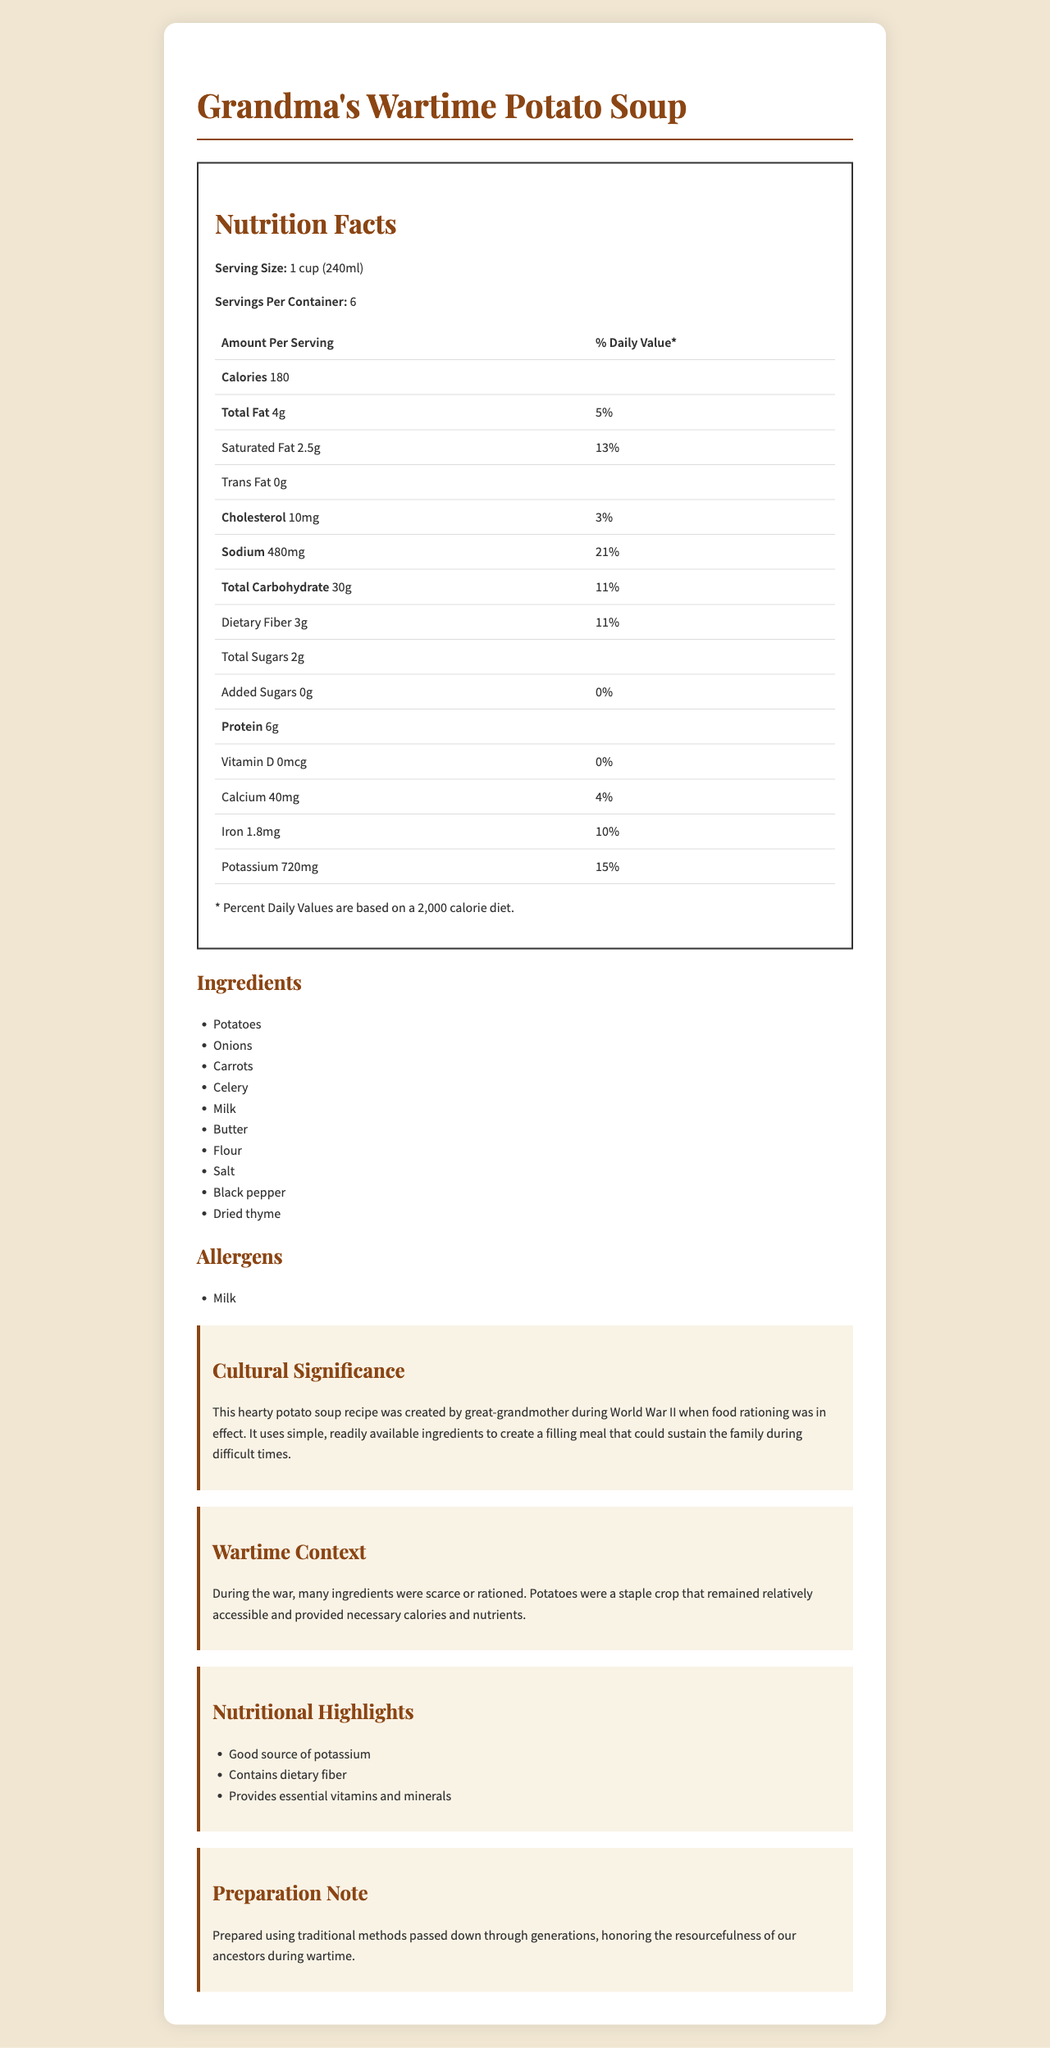what is the serving size for Grandma's Wartime Potato Soup? The serving size is clearly listed as "1 cup (240ml)" on the nutrition label.
Answer: 1 cup (240ml) How many servings are in one container? The document specifies there are 6 servings per container.
Answer: 6 How much sodium is in each serving? The amount of sodium per serving is listed as 480mg.
Answer: 480mg What percentage of the daily value is the total fat per serving? The total fat per serving is 4g, and the daily value percentage is shown as 5%.
Answer: 5% Which nutrient has the highest daily value percentage? Sodium has the highest daily value percentage at 21%.
Answer: Sodium List three ingredients found in Grandma's Wartime Potato Soup. These ingredients are listed in the "Ingredients" section of the document.
Answer: Potatoes, Onions, Carrots How much dietary fiber does one serving contain? The "Dietary fiber" content per serving is listed as 3g.
Answer: 3g What is the protein content per serving? The protein content per serving is indicated to be 6g.
Answer: 6g which of the following vitamins or minerals is NOT present in significant amounts in this soup?
A. Calcium
B. Iron
C. Vitamin D
D. Potassium The document lists Vitamin D as 0mcg or 0% of the daily value, indicating it is not present in significant amounts.
Answer: C. Vitamin D Which ingredient likely accounts for the milk allergen warning? 
I. Potatoes
II. Onions
III. Milk
IV. Celery Milk is both listed as an ingredient and the allergen warning states that the product contains milk.
Answer: III. Milk Is there any added sugar in this soup? The document states that added sugars amount to 0g, and the daily value is 0%.
Answer: No Summarize the main idea of this document. The document covers various aspects of Grandma's Wartime Potato Soup, detailing its nutritional profile, ingredients, allergens, historical context, and cultural significance.
Answer: The document presents the nutrition facts, ingredients, and cultural significance of Grandma's Wartime Potato Soup, a traditional recipe created during World War II. It includes nutritional information such as calorie content, fats, sodium, and various vitamins and minerals, alongside ingredient and allergen details. The cultural and historical context highlights the recipe's importance during the war when food was rationed and potatoes were a staple. What was the main reason potatoes were used in the original recipe created during World War II? The "wartime context" section of the document explains that potatoes were a common and accessible food source during the war, offering essential calories and nutrients.
Answer: Potatoes were a staple crop that remained relatively accessible and provided necessary calories and nutrients. What can be inferred about the dietary habits during wartime from this document? The "cultural significance" and "wartime context" sections emphasize the use of basic ingredients due to rationing and scarcity, reflecting the need for resourcefulness during wartime.
Answer: They utilized simple and readily available ingredients to create filling meals that could sustain families during difficult times. Which of the following highlights the nutritional benefits of Grandma's Wartime Potato Soup?
A. High in protein
B. Good source of potassium
C. Low in sodium
D. Contains high added sugars Among the listed highlights in the document, "Good source of potassium" is mentioned, whereas the other options are either incorrect or not emphasized.
Answer: B. Good source of potassium Describe one way the soup honors the resourcefulness of ancestors during wartime. The "preparation note" and the general description highlight that the recipe uses common, accessible ingredients to sustain the family, reflecting the ingenuity needed during war periods.
Answer: The soup uses simple and readily available ingredients to create a filling meal, which mirrors the resourcefulness required during times of rationing. Is the Vitamin D content in the soup significant for daily nutritional requirements? The Vitamin D content is listed as 0mcg, which is 0% of the daily value, implying it is not significant.
Answer: No How is the cultural significance of the soup described? The "cultural significance" section explains that the soup recipe was developed during wartime to sustain the family with limited resources.
Answer: It was created by great-grandmother during World War II using simple, available ingredients to provide a filling meal during times of rationing. What facts about the soup cannot be determined from the document? While the document provides nutritional information, ingredients, and a general context, it does not detail the exact historical authenticity or the step-by-step preparation method of the soup.
Answer: The origin and historical accuracy of the recipe, and the exact preparation method. 